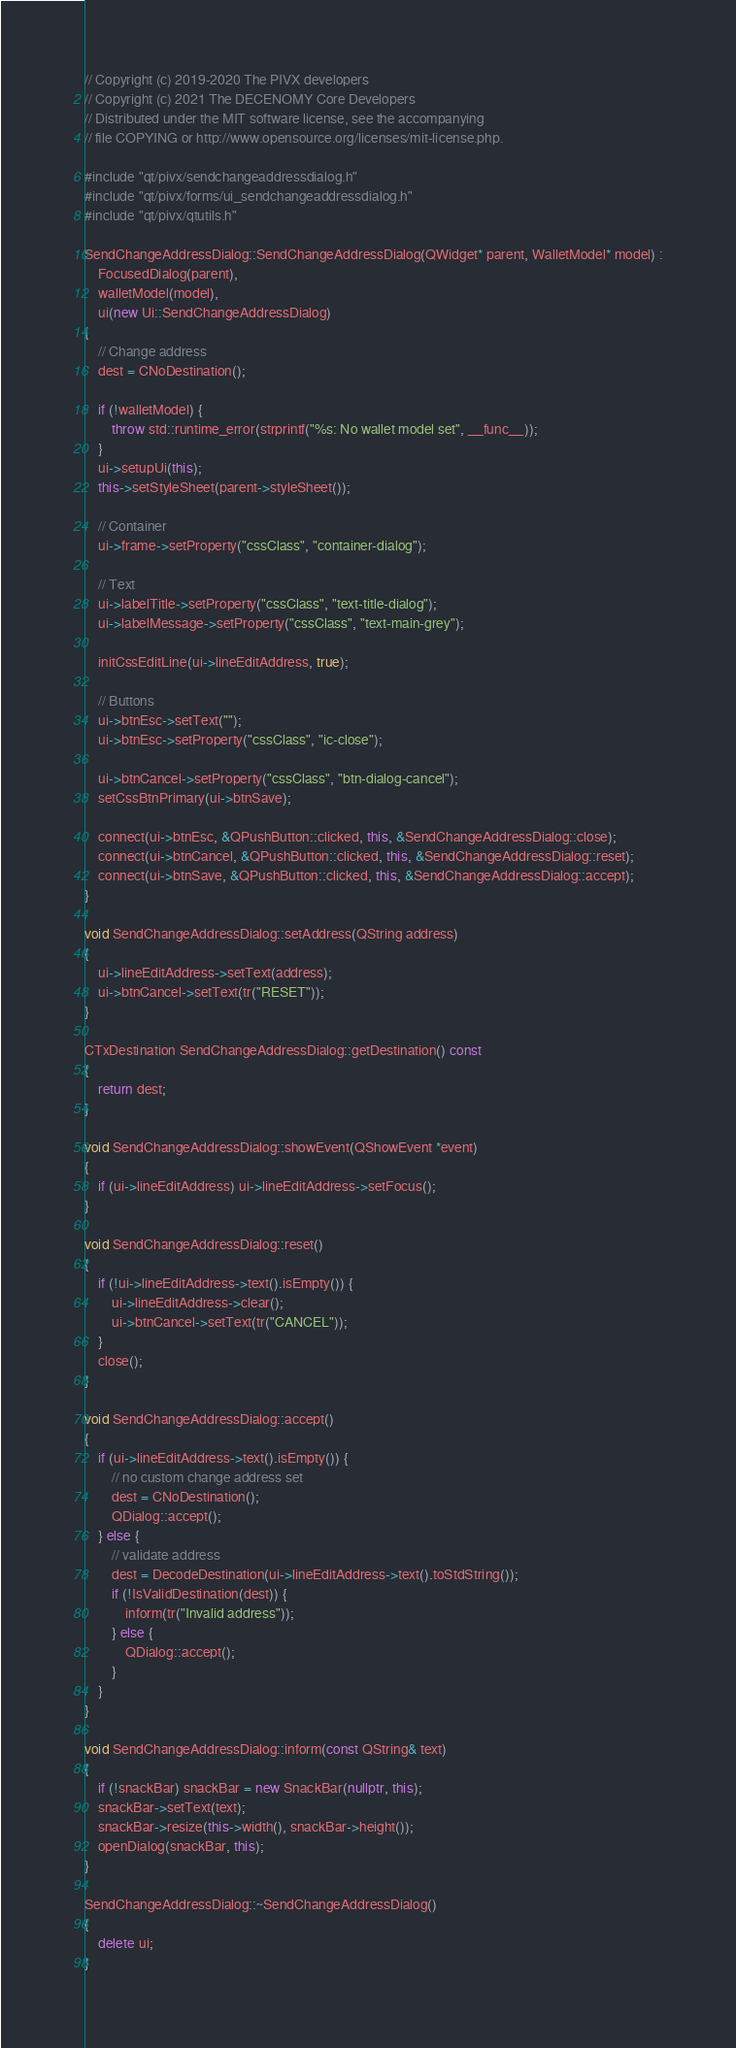Convert code to text. <code><loc_0><loc_0><loc_500><loc_500><_C++_>// Copyright (c) 2019-2020 The PIVX developers
// Copyright (c) 2021 The DECENOMY Core Developers
// Distributed under the MIT software license, see the accompanying
// file COPYING or http://www.opensource.org/licenses/mit-license.php.

#include "qt/pivx/sendchangeaddressdialog.h"
#include "qt/pivx/forms/ui_sendchangeaddressdialog.h"
#include "qt/pivx/qtutils.h"

SendChangeAddressDialog::SendChangeAddressDialog(QWidget* parent, WalletModel* model) :
    FocusedDialog(parent),
    walletModel(model),
    ui(new Ui::SendChangeAddressDialog)
{
    // Change address
    dest = CNoDestination();

    if (!walletModel) {
        throw std::runtime_error(strprintf("%s: No wallet model set", __func__));
    }
    ui->setupUi(this);
    this->setStyleSheet(parent->styleSheet());

    // Container
    ui->frame->setProperty("cssClass", "container-dialog");

    // Text
    ui->labelTitle->setProperty("cssClass", "text-title-dialog");
    ui->labelMessage->setProperty("cssClass", "text-main-grey");

    initCssEditLine(ui->lineEditAddress, true);

    // Buttons
    ui->btnEsc->setText("");
    ui->btnEsc->setProperty("cssClass", "ic-close");

    ui->btnCancel->setProperty("cssClass", "btn-dialog-cancel");
    setCssBtnPrimary(ui->btnSave);

    connect(ui->btnEsc, &QPushButton::clicked, this, &SendChangeAddressDialog::close);
    connect(ui->btnCancel, &QPushButton::clicked, this, &SendChangeAddressDialog::reset);
    connect(ui->btnSave, &QPushButton::clicked, this, &SendChangeAddressDialog::accept);
}

void SendChangeAddressDialog::setAddress(QString address)
{
    ui->lineEditAddress->setText(address);
    ui->btnCancel->setText(tr("RESET"));
}

CTxDestination SendChangeAddressDialog::getDestination() const
{
    return dest;
}

void SendChangeAddressDialog::showEvent(QShowEvent *event)
{
    if (ui->lineEditAddress) ui->lineEditAddress->setFocus();
}

void SendChangeAddressDialog::reset()
{
    if (!ui->lineEditAddress->text().isEmpty()) {
        ui->lineEditAddress->clear();
        ui->btnCancel->setText(tr("CANCEL"));
    }
    close();
}

void SendChangeAddressDialog::accept()
{
    if (ui->lineEditAddress->text().isEmpty()) {
        // no custom change address set
        dest = CNoDestination();
        QDialog::accept();
    } else {
        // validate address
        dest = DecodeDestination(ui->lineEditAddress->text().toStdString());
        if (!IsValidDestination(dest)) {
            inform(tr("Invalid address"));
        } else {
            QDialog::accept();
        }
    }
}

void SendChangeAddressDialog::inform(const QString& text)
{
    if (!snackBar) snackBar = new SnackBar(nullptr, this);
    snackBar->setText(text);
    snackBar->resize(this->width(), snackBar->height());
    openDialog(snackBar, this);
}

SendChangeAddressDialog::~SendChangeAddressDialog()
{
    delete ui;
}
</code> 